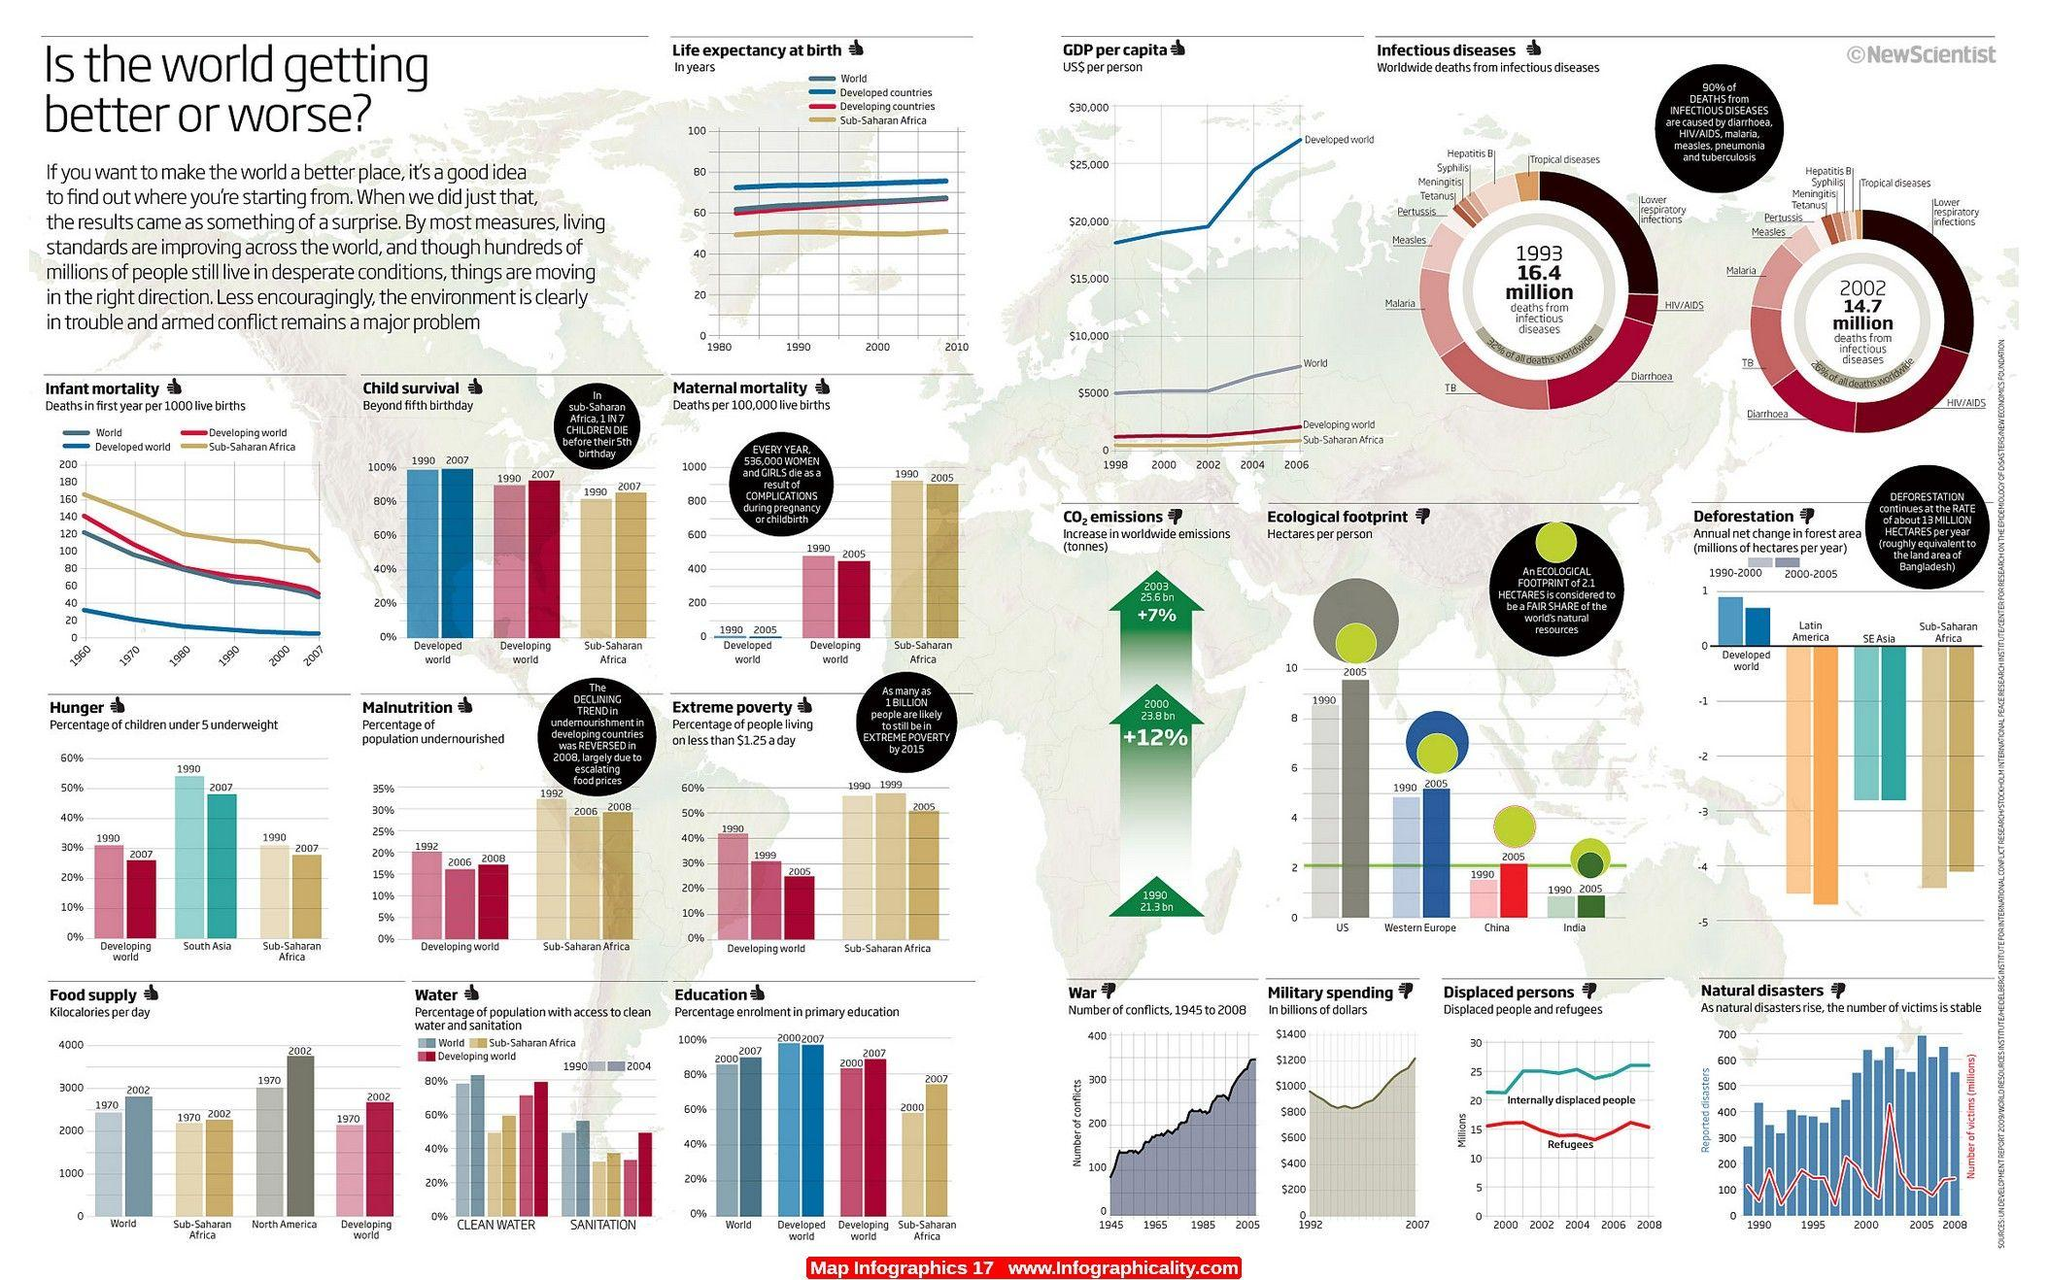Indicate a few pertinent items in this graphic. The GDP per capita graph shows that the Developed world had the highest increase in GDP per capita from 2002-2006. The increase in CO2 emissions from 2000 to 2003 was approximately 7%. In the graph depicting war in 2005, there were approximately 350 conflicts. The number of deaths due to tuberculosis was higher in 1993. Escalating food prices from 2006 to 2008 were the primary reason for the increase in malnutrition percentage during that time period. 